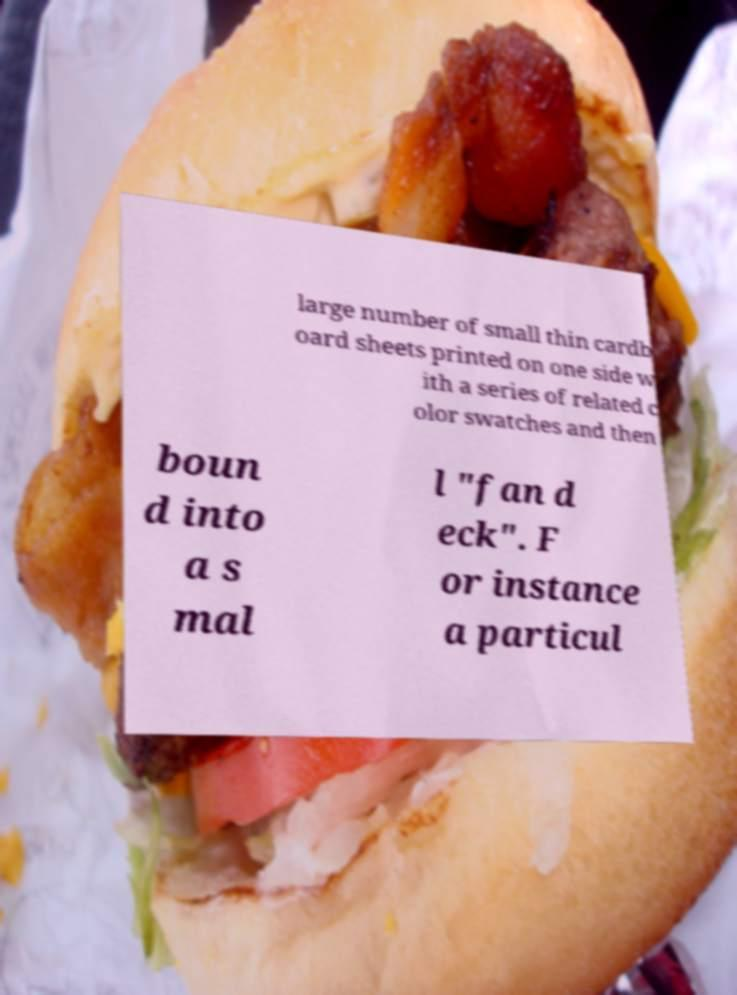Could you assist in decoding the text presented in this image and type it out clearly? large number of small thin cardb oard sheets printed on one side w ith a series of related c olor swatches and then boun d into a s mal l "fan d eck". F or instance a particul 